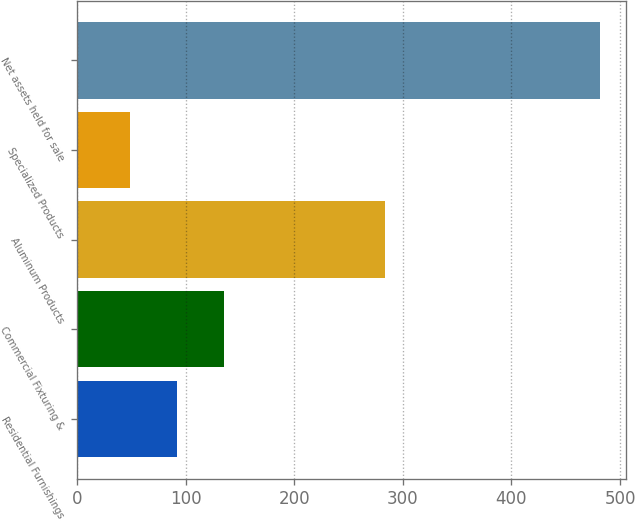Convert chart to OTSL. <chart><loc_0><loc_0><loc_500><loc_500><bar_chart><fcel>Residential Furnishings<fcel>Commercial Fixturing &<fcel>Aluminum Products<fcel>Specialized Products<fcel>Net assets held for sale<nl><fcel>91.94<fcel>135.18<fcel>283.5<fcel>48.7<fcel>481.1<nl></chart> 